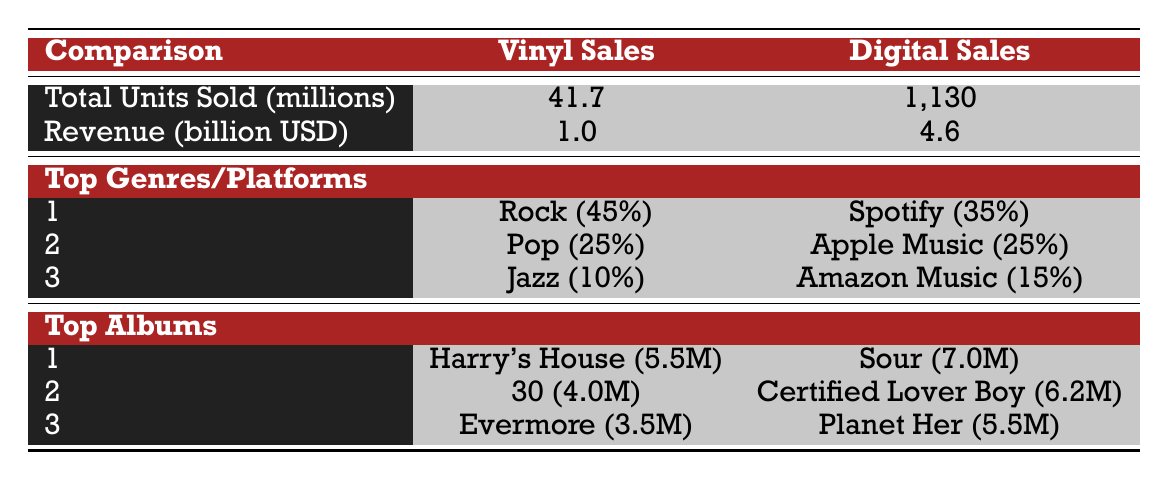What was the total revenue from vinyl sales in 2022? According to the table, the revenue from vinyl sales is listed as 1.0 billion USD. Therefore, the answer is directly taken from the table.
Answer: 1.0 billion USD Which genre had the highest percentage in vinyl sales? The table shows that Rock was the top genre with 45%. This is obtained directly from the "Top Genres" section for vinyl sales.
Answer: Rock What is the difference in total units sold between digital and vinyl sales? The total units sold for vinyl is 41.7 million and for digital is 1,130 million. The difference is calculated as 1,130 - 41.7 = 1,088.3 million.
Answer: 1,088.3 million Did Adele's album "30" sell more units than Harry Styles' "Harry's House"? "30" sold 4.0 million units while "Harry's House" sold 5.5 million units according to the "Top Albums" for vinyl sales. Since 4.0 million is less than 5.5 million, the answer is no.
Answer: No Which digital platform had the second-highest sales percentage? The "Top Platforms" section indicates that after Spotify (35%), Apple Music is next with 25%. This information allows us to identify the second-highest platform easily.
Answer: Apple Music What was the total vinyl sales in terms of millions? The table states that total vinyl sales were 41.7 million. This figure is explicitly mentioned in the "Total Units Sold" row under vinyl sales.
Answer: 41.7 million Which album sold the least among the top vinyl albums? From the "Top Albums" section, "Evermore" sold 3.5 million units, which is less than "Harry's House" and "30". This comparison determines the least sold album.
Answer: Evermore How much more revenue did digital sales generate compared to vinyl sales? Vinyl sales generated 1.0 billion USD and digital sales generated 4.6 billion USD. The difference is 4.6 - 1.0 = 3.6 billion USD, indicating how much more revenue digital sales generated.
Answer: 3.6 billion USD What is the total percentage of the top three genres in vinyl sales? Adding the percentages of the top three genres in vinyl sales gives 45% (Rock) + 25% (Pop) + 10% (Jazz) = 80%. This calculation shows the cumulative genre representation.
Answer: 80% 